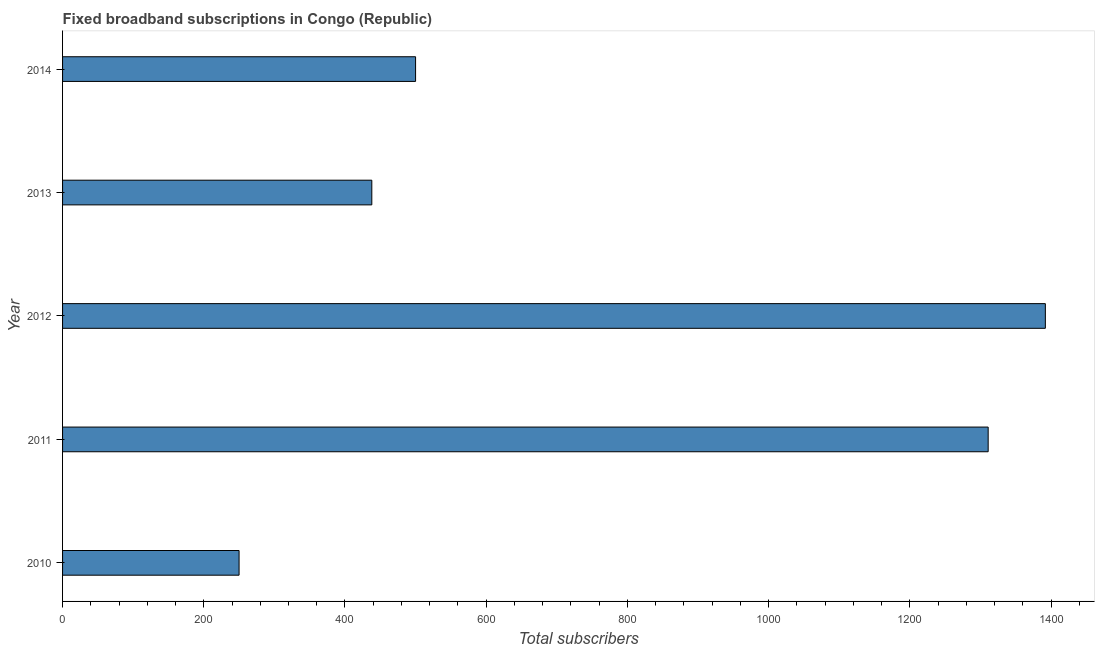Does the graph contain any zero values?
Provide a succinct answer. No. What is the title of the graph?
Your answer should be very brief. Fixed broadband subscriptions in Congo (Republic). What is the label or title of the X-axis?
Your answer should be very brief. Total subscribers. What is the label or title of the Y-axis?
Ensure brevity in your answer.  Year. Across all years, what is the maximum total number of fixed broadband subscriptions?
Your response must be concise. 1392. Across all years, what is the minimum total number of fixed broadband subscriptions?
Provide a short and direct response. 250. In which year was the total number of fixed broadband subscriptions minimum?
Make the answer very short. 2010. What is the sum of the total number of fixed broadband subscriptions?
Offer a terse response. 3891. What is the difference between the total number of fixed broadband subscriptions in 2011 and 2012?
Keep it short and to the point. -81. What is the average total number of fixed broadband subscriptions per year?
Your answer should be very brief. 778. Do a majority of the years between 2014 and 2010 (inclusive) have total number of fixed broadband subscriptions greater than 1360 ?
Your response must be concise. Yes. What is the ratio of the total number of fixed broadband subscriptions in 2010 to that in 2014?
Provide a short and direct response. 0.5. What is the difference between the highest and the second highest total number of fixed broadband subscriptions?
Offer a very short reply. 81. Is the sum of the total number of fixed broadband subscriptions in 2010 and 2011 greater than the maximum total number of fixed broadband subscriptions across all years?
Keep it short and to the point. Yes. What is the difference between the highest and the lowest total number of fixed broadband subscriptions?
Offer a very short reply. 1142. In how many years, is the total number of fixed broadband subscriptions greater than the average total number of fixed broadband subscriptions taken over all years?
Make the answer very short. 2. How many years are there in the graph?
Keep it short and to the point. 5. What is the difference between two consecutive major ticks on the X-axis?
Give a very brief answer. 200. What is the Total subscribers of 2010?
Provide a succinct answer. 250. What is the Total subscribers of 2011?
Make the answer very short. 1311. What is the Total subscribers in 2012?
Ensure brevity in your answer.  1392. What is the Total subscribers of 2013?
Your answer should be very brief. 438. What is the difference between the Total subscribers in 2010 and 2011?
Your answer should be compact. -1061. What is the difference between the Total subscribers in 2010 and 2012?
Make the answer very short. -1142. What is the difference between the Total subscribers in 2010 and 2013?
Offer a terse response. -188. What is the difference between the Total subscribers in 2010 and 2014?
Offer a terse response. -250. What is the difference between the Total subscribers in 2011 and 2012?
Provide a short and direct response. -81. What is the difference between the Total subscribers in 2011 and 2013?
Offer a terse response. 873. What is the difference between the Total subscribers in 2011 and 2014?
Ensure brevity in your answer.  811. What is the difference between the Total subscribers in 2012 and 2013?
Provide a short and direct response. 954. What is the difference between the Total subscribers in 2012 and 2014?
Your response must be concise. 892. What is the difference between the Total subscribers in 2013 and 2014?
Your answer should be very brief. -62. What is the ratio of the Total subscribers in 2010 to that in 2011?
Provide a short and direct response. 0.19. What is the ratio of the Total subscribers in 2010 to that in 2012?
Your answer should be compact. 0.18. What is the ratio of the Total subscribers in 2010 to that in 2013?
Your answer should be very brief. 0.57. What is the ratio of the Total subscribers in 2011 to that in 2012?
Give a very brief answer. 0.94. What is the ratio of the Total subscribers in 2011 to that in 2013?
Provide a succinct answer. 2.99. What is the ratio of the Total subscribers in 2011 to that in 2014?
Provide a succinct answer. 2.62. What is the ratio of the Total subscribers in 2012 to that in 2013?
Give a very brief answer. 3.18. What is the ratio of the Total subscribers in 2012 to that in 2014?
Your answer should be very brief. 2.78. What is the ratio of the Total subscribers in 2013 to that in 2014?
Your answer should be very brief. 0.88. 